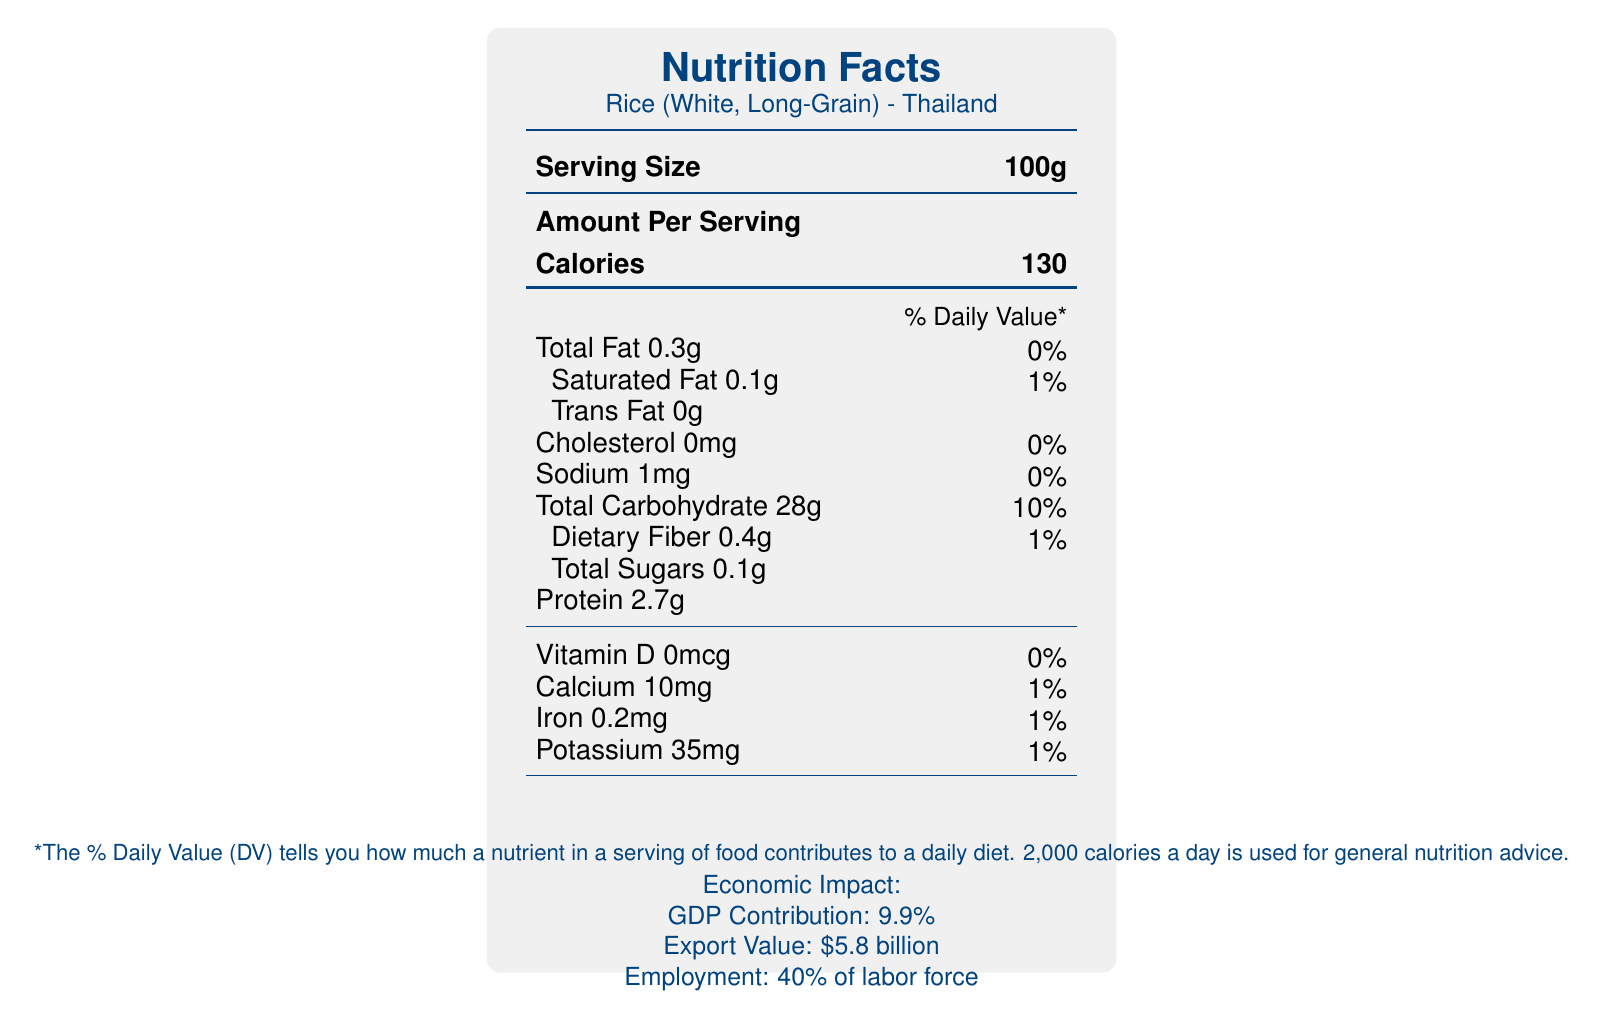what is the serving size of Rice (White, Long-Grain) from Thailand? The serving size is clearly listed as "100g" in the document.
Answer: 100g how many calories are in a serving of Rice (White, Long-Grain)? The document specifies that one serving contains 130 calories.
Answer: 130 what is the total fat content in one serving of Rice (White, Long-Grain)? The total fat content is shown as "Total Fat 0.3g".
Answer: 0.3g what is the % Daily Value of Saturated Fat in one serving of Rice (White, Long-Grain)? It is noted as "Saturated Fat 0.1g" with a % Daily Value of 1%.
Answer: 1% how much iron is in a serving of Rice (White, Long-Grain)? Under the nutrients section, "Iron 0.2mg" is listed.
Answer: 0.2mg Which of the following nutrients has the highest % Daily Value in a serving? A. Total Carbohydrate B. Protein C. Sodium Total Carbohydrate has a % Daily Value of 10%, which is the highest among the listed nutrients.
Answer: A What is the economic impact of Rice (White, Long-Grain) on Thailand? A. Export Value: $5.8 billion B. GDP Contribution: 7.2% C. Employment: 30% of labor force The economic impact section lists the export value as "$5.8 billion".
Answer: A Does the document state the amount of Vitamin D in Rice (White, Long-Grain)? The document mentions "Vitamin D 0mcg".
Answer: Yes Summarize the main points of the document. The document aims to offer a comprehensive overview of the nutritional content of staple foods and their economic significance within Asian economies, using rice from Thailand as a primary example.
Answer: The document titled "Comparative Analysis of Nutrient Profiles in Staple Foods Across Asian Economies" provides detailed nutrient profiles of staple foods from different Asian countries, focusing on rice from Thailand. It further includes information about serving sizes, calories, various nutrients, and their % Daily Values. Additionally, it highlights the economic impact of these staple foods, including GDP contribution, export value, and employment. What is the % Daily Value for Dietary Fiber in one serving of Rice (White, Long-Grain)? The % Daily Value for Dietary Fiber is listed as 1%.
Answer: 1% Is there any information about the agricultural subsidies provided by Thailand? The nutritional facts document does not provide any details on agricultural subsidies, which would be found in a different section focusing on economic analysis.
Answer: Cannot be determined What is the protein content in a serving of Rice (White, Long-Grain)? The document lists the protein content as "Protein 2.7g".
Answer: 2.7g How much potassium is in one serving of Rice (White, Long-Grain)? Potassium content is shown as "Potassium 35mg".
Answer: 35mg 